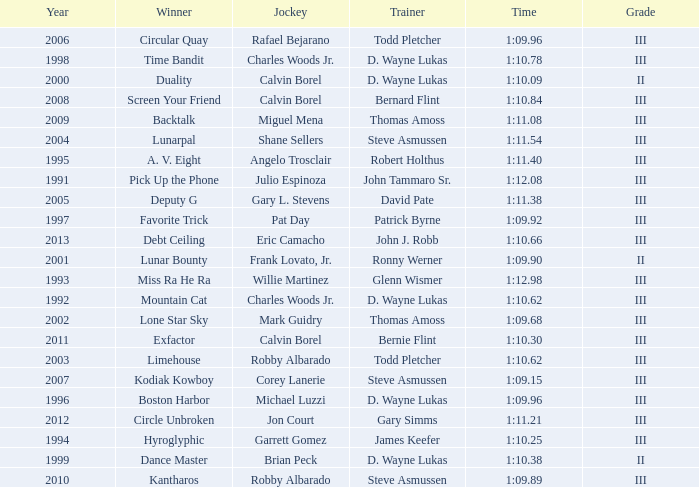Which trainer won the hyroglyphic in a year that was before 2010? James Keefer. 